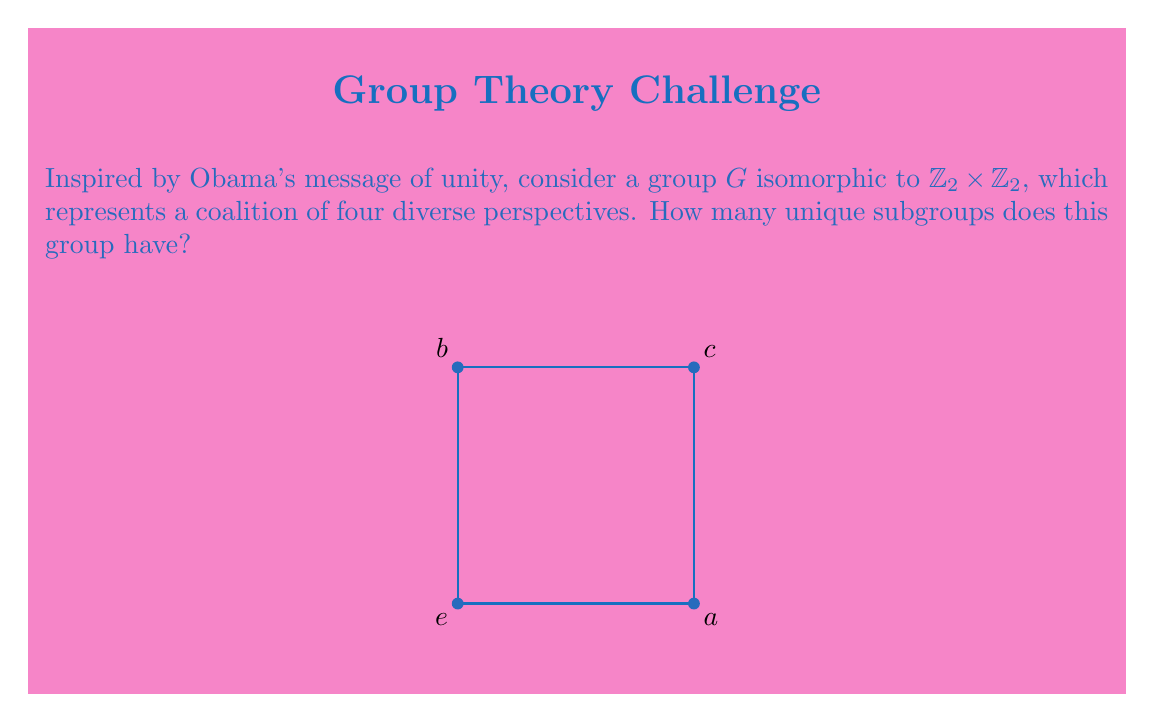Show me your answer to this math problem. Let's approach this step-by-step:

1) First, recall that $\mathbb{Z}_2 \times \mathbb{Z}_2$ is the Klein four-group, with four elements: $\{e, a, b, c\}$.

2) To find all subgroups, we need to consider all possible combinations of elements that form a group:

   a) The trivial subgroup $\{e\}$ is always present.
   
   b) Each non-identity element generates a subgroup of order 2:
      $\langle a \rangle = \{e, a\}$
      $\langle b \rangle = \{e, b\}$
      $\langle c \rangle = \{e, c\}$

   c) The entire group $G = \{e, a, b, c\}$ is also a subgroup of itself.

3) We can verify that there are no other subgroups:
   - Any subgroup containing two non-identity elements must contain the third (their product), and thus would be the entire group.

4) Therefore, we have found all subgroups:
   - 1 subgroup of order 1: $\{e\}$
   - 3 subgroups of order 2: $\{e, a\}$, $\{e, b\}$, $\{e, c\}$
   - 1 subgroup of order 4: $G$ itself

5) In total, we have $1 + 3 + 1 = 5$ unique subgroups.

This result demonstrates that even in a small group, there can be multiple ways to form coalitions, reflecting the importance of considering various perspectives in leadership.
Answer: 5 